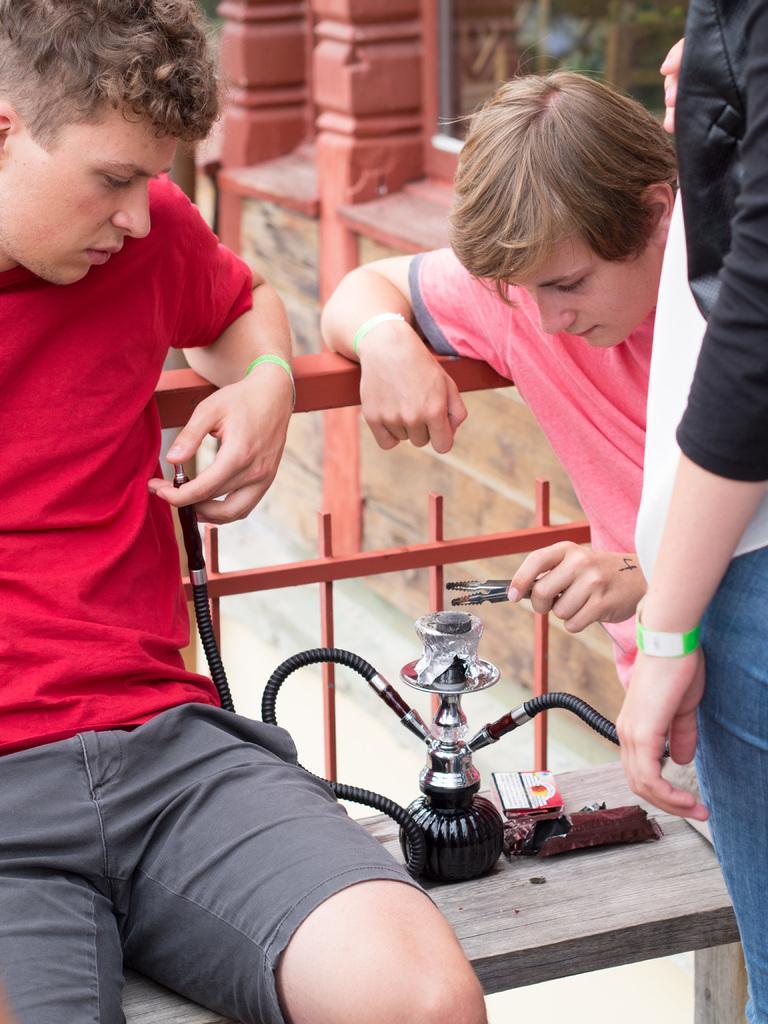Could you give a brief overview of what you see in this image? In this image I can see on the left side a man is sitting on the bench, he wore a red color t-shirt. In the middle there is the hookah pot, on the right side a man is touching and seeing it. 